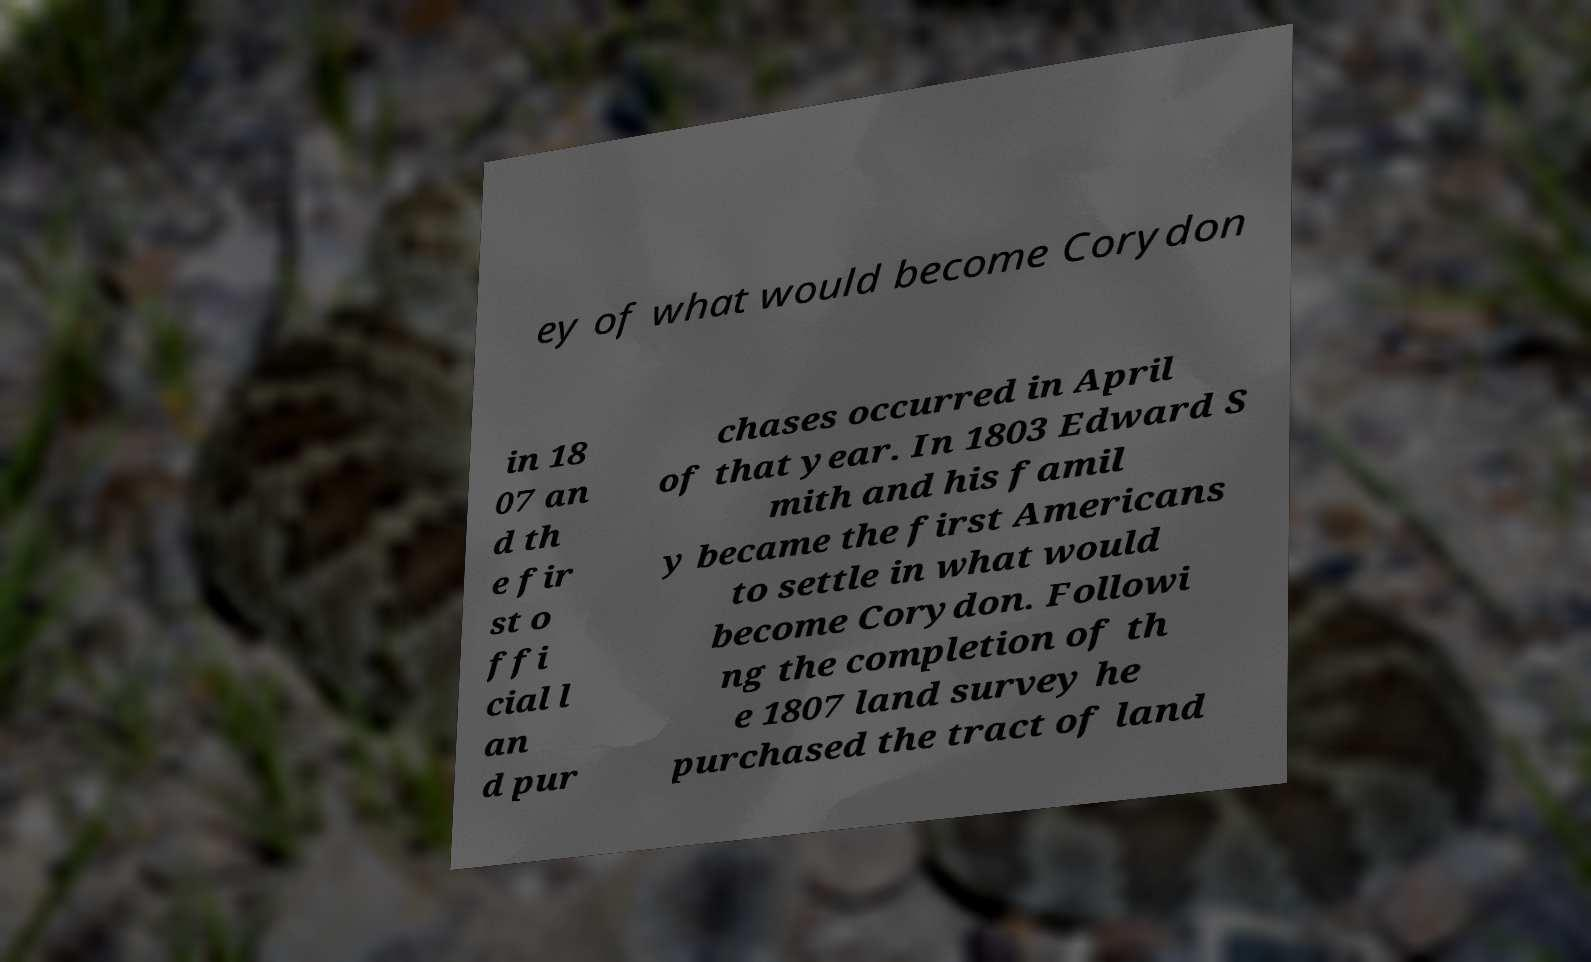Can you accurately transcribe the text from the provided image for me? ey of what would become Corydon in 18 07 an d th e fir st o ffi cial l an d pur chases occurred in April of that year. In 1803 Edward S mith and his famil y became the first Americans to settle in what would become Corydon. Followi ng the completion of th e 1807 land survey he purchased the tract of land 